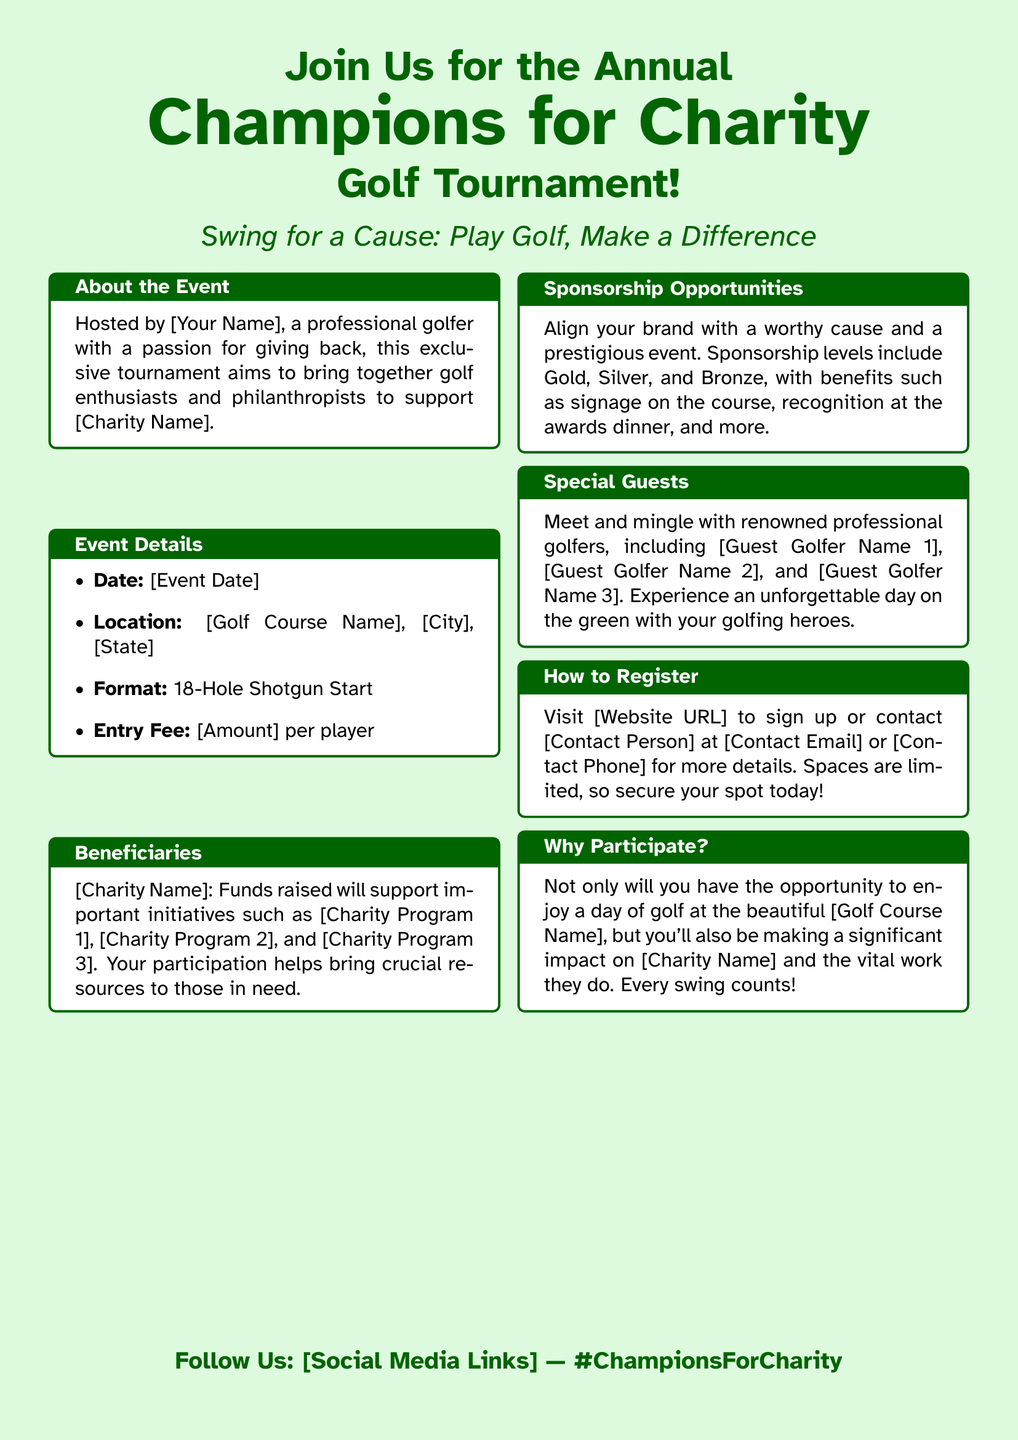What is the name of the tournament? The name of the tournament is located at the top of the document.
Answer: Champions for Charity Who is hosting the event? The host is specified in the about section of the document.
Answer: [Your Name] What is the entry fee for players? The entry fee is mentioned in the event details section.
Answer: [Amount] When is the tournament scheduled? The date of the event is specified in the event details section.
Answer: [Event Date] What type of event is this? The format of the event is described in the event details.
Answer: 18-Hole Shotgun Start What charity is being supported? The charity name is provided in the beneficiaries section.
Answer: [Charity Name] What is one of the charity programs mentioned? The programs supported by the charity can be found in the beneficiaries section.
Answer: [Charity Program 1] What kind of sponsorship levels are offered? The sponsorship levels are outlined in the sponsorship opportunities section.
Answer: Gold, Silver, and Bronze Who are some of the special guests? Guest golfers are named in the special guests section.
Answer: [Guest Golfer Name 1] 